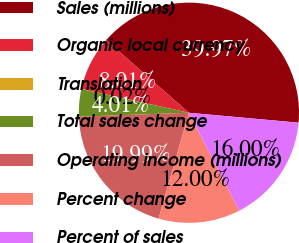Convert chart to OTSL. <chart><loc_0><loc_0><loc_500><loc_500><pie_chart><fcel>Sales (millions)<fcel>Organic local currency<fcel>Translation<fcel>Total sales change<fcel>Operating income (millions)<fcel>Percent change<fcel>Percent of sales<nl><fcel>39.97%<fcel>8.01%<fcel>0.02%<fcel>4.01%<fcel>19.99%<fcel>12.0%<fcel>16.0%<nl></chart> 